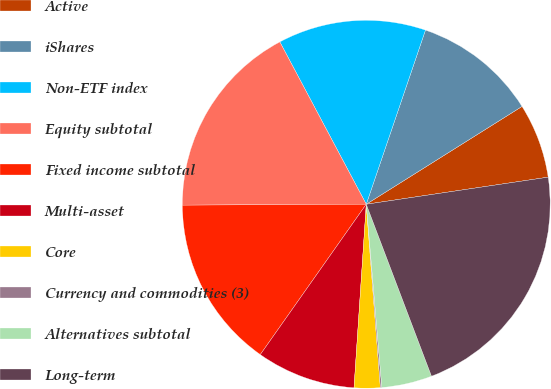Convert chart to OTSL. <chart><loc_0><loc_0><loc_500><loc_500><pie_chart><fcel>Active<fcel>iShares<fcel>Non-ETF index<fcel>Equity subtotal<fcel>Fixed income subtotal<fcel>Multi-asset<fcel>Core<fcel>Currency and commodities (3)<fcel>Alternatives subtotal<fcel>Long-term<nl><fcel>6.57%<fcel>10.86%<fcel>13.0%<fcel>17.29%<fcel>15.15%<fcel>8.71%<fcel>2.28%<fcel>0.13%<fcel>4.42%<fcel>21.58%<nl></chart> 